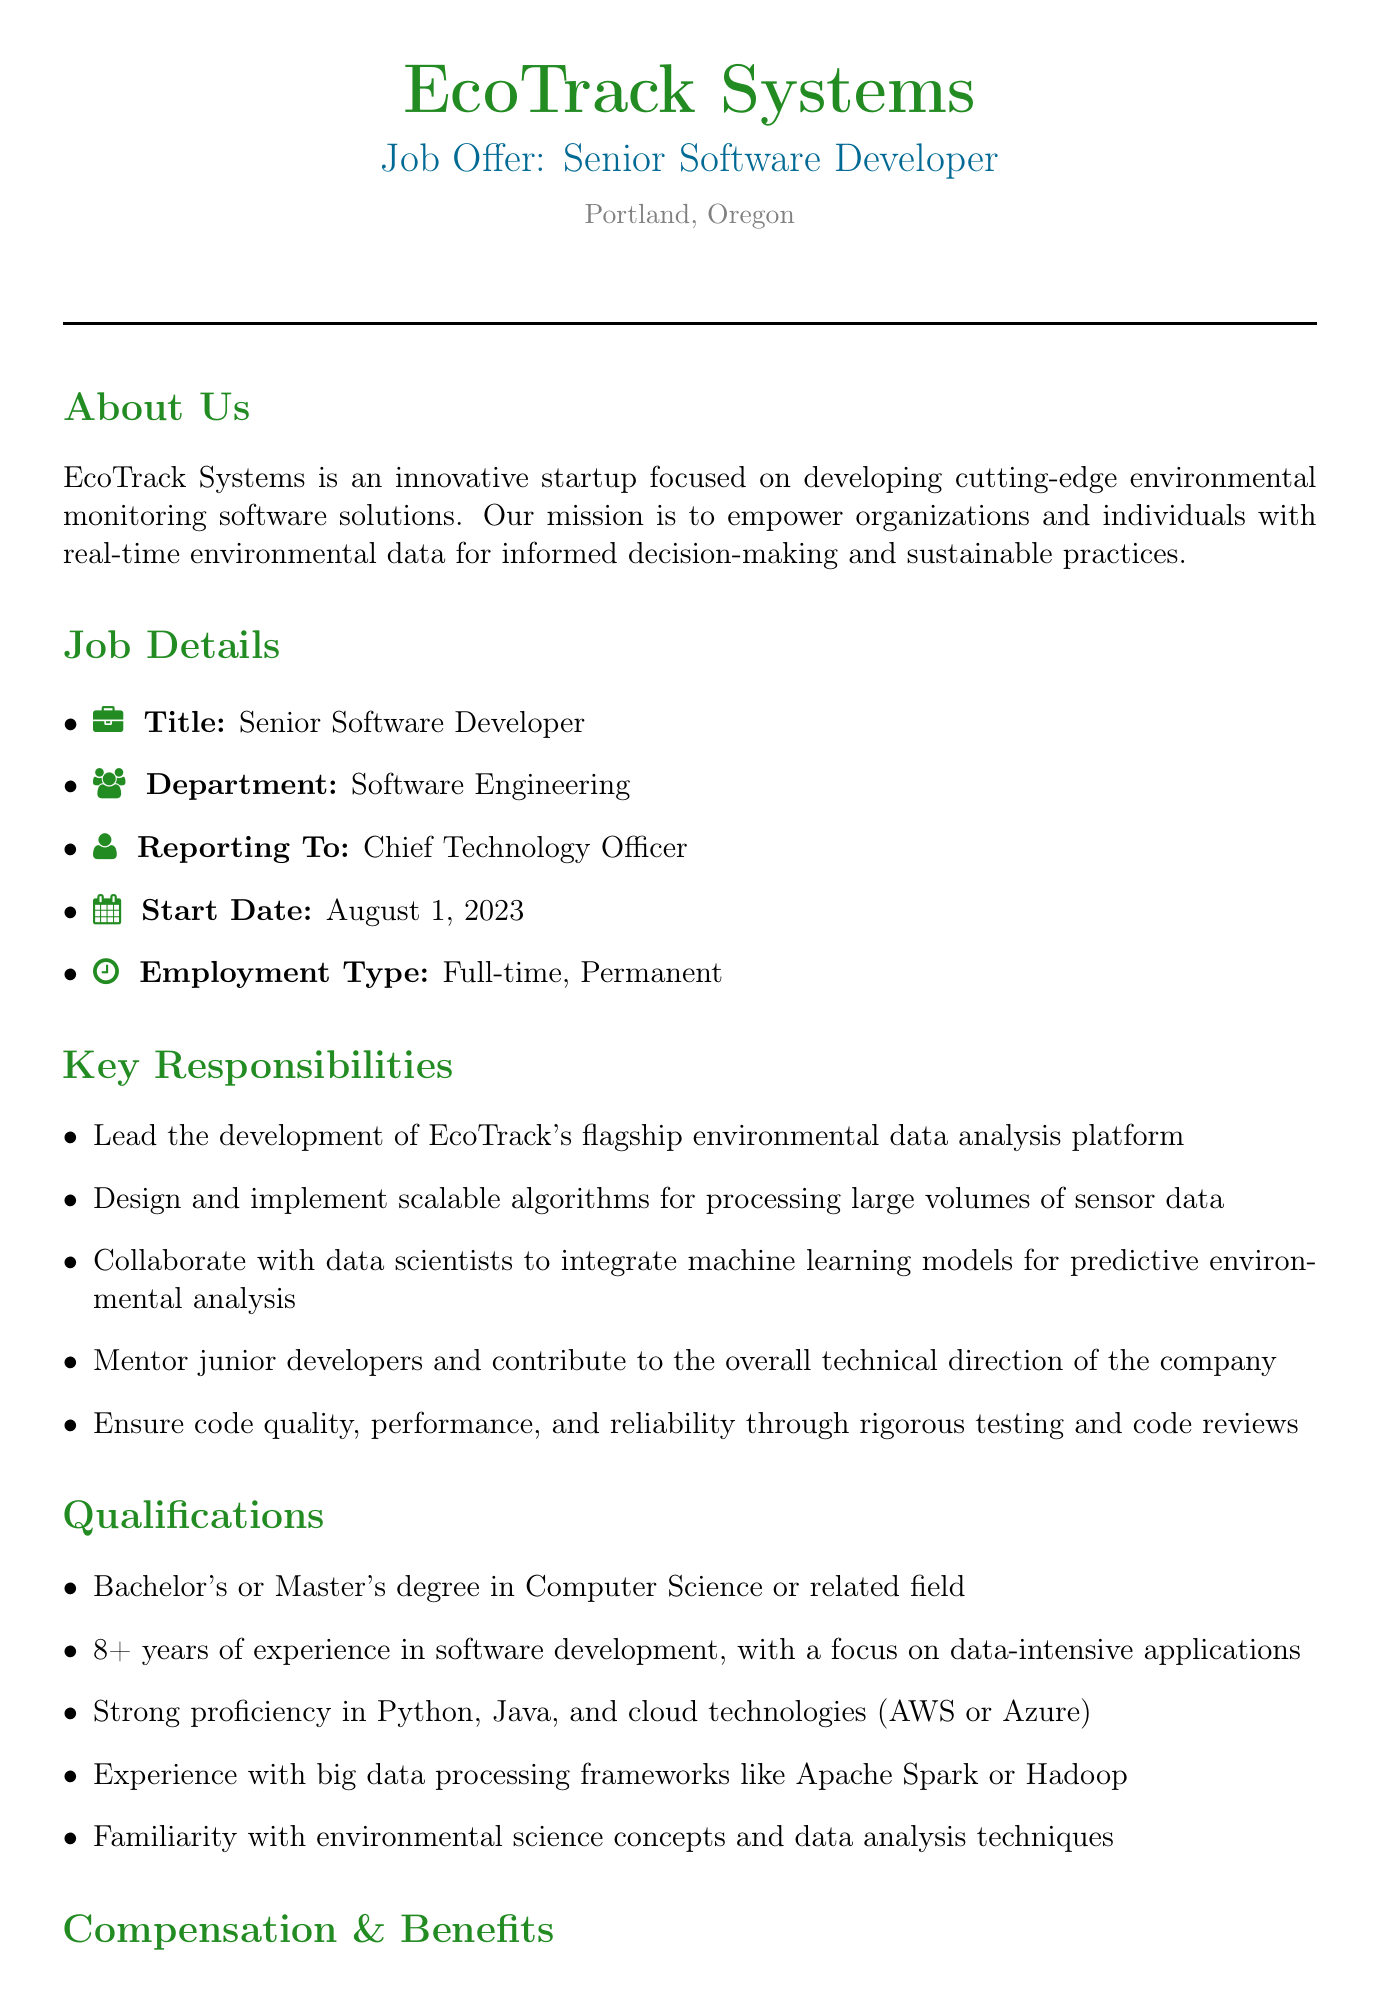What is the name of the company? The company name is mentioned at the top of the document as EcoTrack Systems.
Answer: EcoTrack Systems What is the job title for the position offered? The job title is listed in the job details section as Senior Software Developer.
Answer: Senior Software Developer Who does this position report to? The document specifies that this position reports to the Chief Technology Officer.
Answer: Chief Technology Officer What is the start date for this position? The start date is provided in the job details and is mentioned as August 1, 2023.
Answer: August 1, 2023 How many years of experience are required for the position? The qualifications section indicates a requirement of 8+ years of experience in software development.
Answer: 8+ years What is the base salary range for this position? The document outlines the base salary range from $140,000 to $160,000 per year.
Answer: $140,000 - $160,000 per year What are the benefits included in the compensation package? The benefits section lists several items including comprehensive health, dental, and vision insurance.
Answer: Comprehensive health, dental, and vision insurance What is the application deadline? The application process section states the deadline is July 15, 2023.
Answer: July 15, 2023 What is a key responsibility for this position? The responsibilities section highlights leading the development of EcoTrack's flagship environmental data analysis platform.
Answer: Lead the development of EcoTrack's flagship environmental data analysis platform What does EcoTrack Systems value in its team culture? The team culture section mentions a commitment to work-life balance as one of its values.
Answer: Commitment to work-life balance 